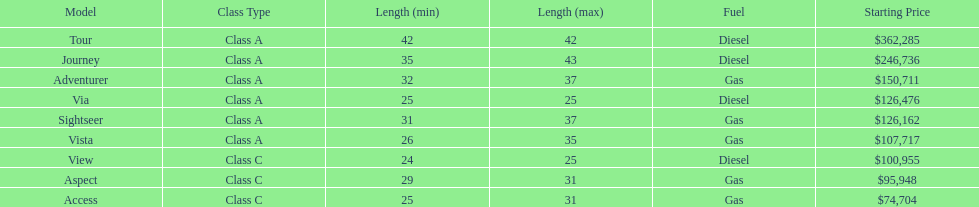How long is the aspect? 29'-31'. 